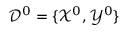Convert formula to latex. <formula><loc_0><loc_0><loc_500><loc_500>\mathcal { D } ^ { 0 } = \{ \mathcal { X } ^ { 0 } , \mathcal { Y } ^ { 0 } \}</formula> 